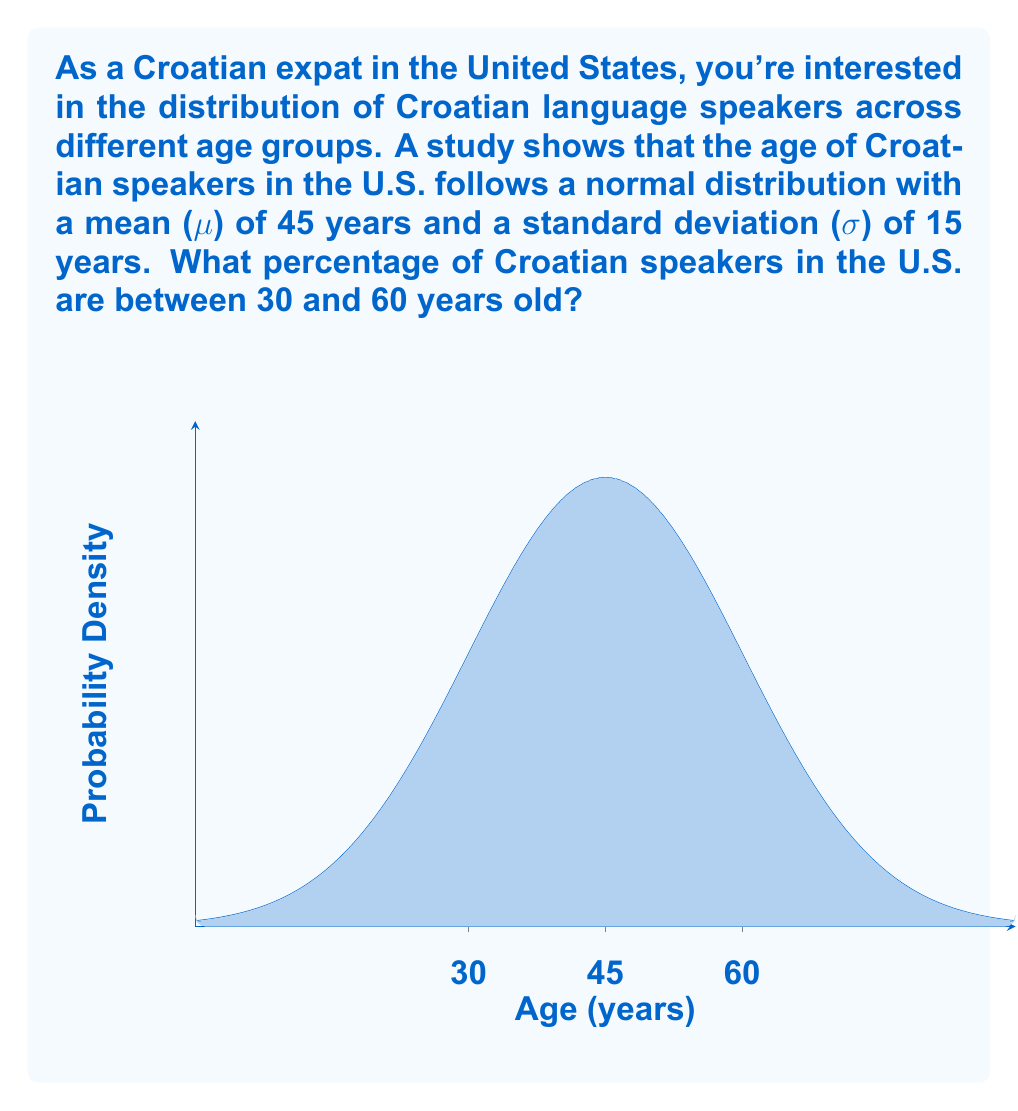Solve this math problem. To solve this problem, we need to use the properties of the normal distribution and the concept of z-scores. Let's break it down step-by-step:

1) First, we need to calculate the z-scores for the age limits 30 and 60:

   For 30 years: $z_1 = \frac{30 - \mu}{\sigma} = \frac{30 - 45}{15} = -1$

   For 60 years: $z_2 = \frac{60 - \mu}{\sigma} = \frac{60 - 45}{15} = 1$

2) Now, we need to find the area under the standard normal curve between these z-scores. This area represents the probability of a Croatian speaker being between 30 and 60 years old.

3) We can use the standard normal distribution table or a calculator to find the area between z = -1 and z = 1.

4) The area under the standard normal curve from z = -1 to z = 1 is approximately 0.6826.

5) To convert this to a percentage, we multiply by 100:

   $0.6826 \times 100 = 68.26\%$

Therefore, approximately 68.26% of Croatian speakers in the U.S. are between 30 and 60 years old.
Answer: 68.26% 